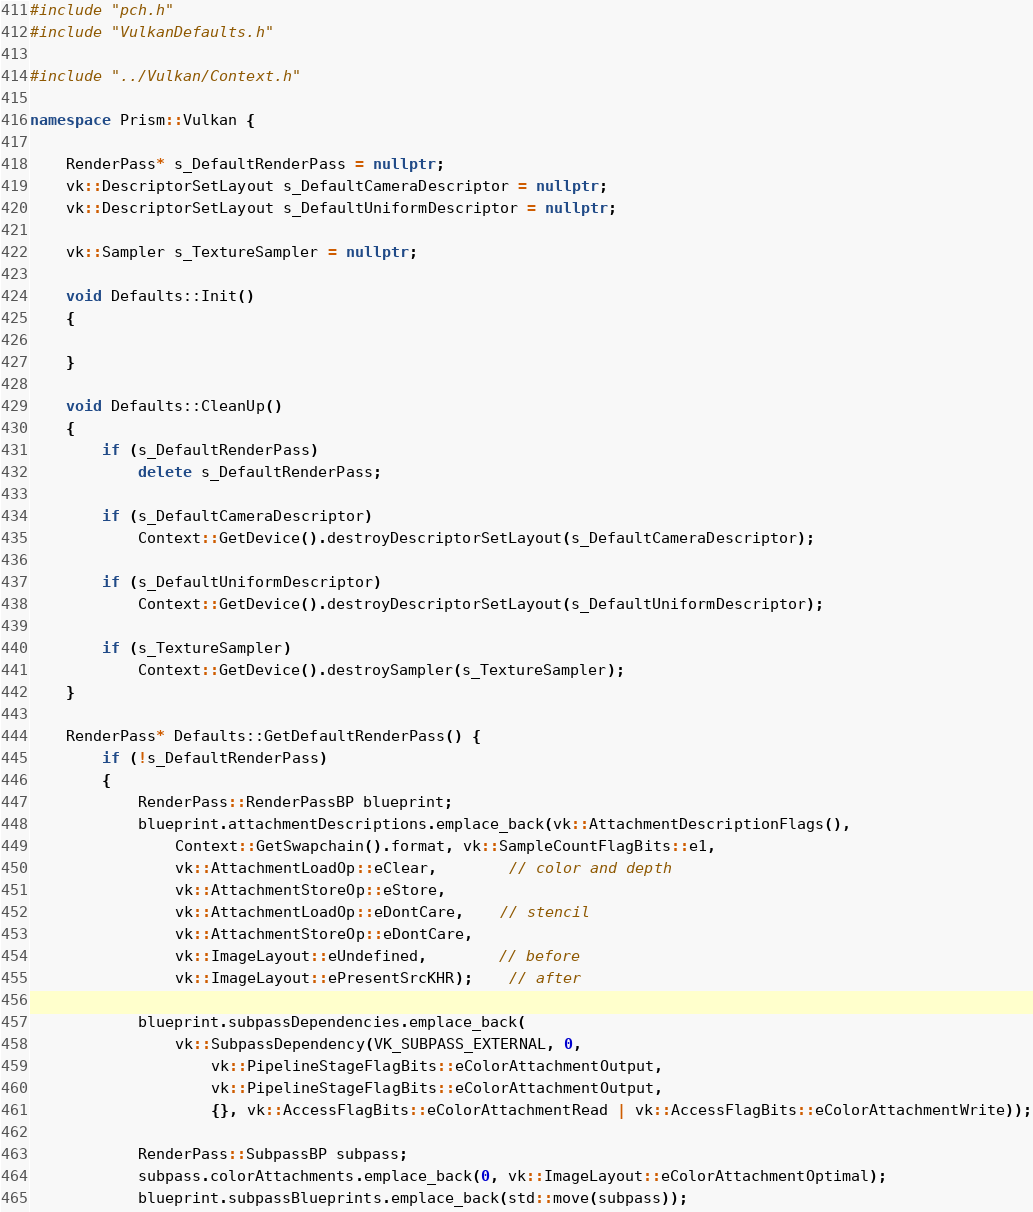Convert code to text. <code><loc_0><loc_0><loc_500><loc_500><_C++_>#include "pch.h"
#include "VulkanDefaults.h"

#include "../Vulkan/Context.h"

namespace Prism::Vulkan {

	RenderPass* s_DefaultRenderPass = nullptr;
	vk::DescriptorSetLayout s_DefaultCameraDescriptor = nullptr;
	vk::DescriptorSetLayout s_DefaultUniformDescriptor = nullptr;

	vk::Sampler s_TextureSampler = nullptr;

	void Defaults::Init()
	{

	}

	void Defaults::CleanUp()
	{
		if (s_DefaultRenderPass)
			delete s_DefaultRenderPass;

		if (s_DefaultCameraDescriptor)
			Context::GetDevice().destroyDescriptorSetLayout(s_DefaultCameraDescriptor);

		if (s_DefaultUniformDescriptor)
			Context::GetDevice().destroyDescriptorSetLayout(s_DefaultUniformDescriptor);

		if (s_TextureSampler)
			Context::GetDevice().destroySampler(s_TextureSampler);
	}

	RenderPass* Defaults::GetDefaultRenderPass() {
		if (!s_DefaultRenderPass)
		{
			RenderPass::RenderPassBP blueprint;
			blueprint.attachmentDescriptions.emplace_back(vk::AttachmentDescriptionFlags(),
				Context::GetSwapchain().format, vk::SampleCountFlagBits::e1,
				vk::AttachmentLoadOp::eClear,		// color and depth
				vk::AttachmentStoreOp::eStore,
				vk::AttachmentLoadOp::eDontCare,	// stencil
				vk::AttachmentStoreOp::eDontCare,
				vk::ImageLayout::eUndefined,		// before
				vk::ImageLayout::ePresentSrcKHR);	// after

			blueprint.subpassDependencies.emplace_back(
				vk::SubpassDependency(VK_SUBPASS_EXTERNAL, 0,
					vk::PipelineStageFlagBits::eColorAttachmentOutput,
					vk::PipelineStageFlagBits::eColorAttachmentOutput,
					{}, vk::AccessFlagBits::eColorAttachmentRead | vk::AccessFlagBits::eColorAttachmentWrite));

			RenderPass::SubpassBP subpass;
			subpass.colorAttachments.emplace_back(0, vk::ImageLayout::eColorAttachmentOptimal);
			blueprint.subpassBlueprints.emplace_back(std::move(subpass));
</code> 